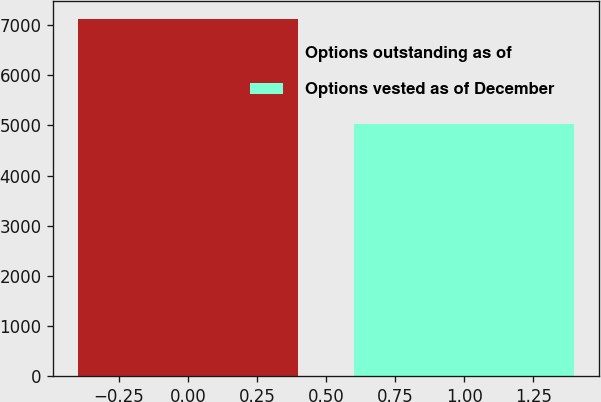Convert chart to OTSL. <chart><loc_0><loc_0><loc_500><loc_500><bar_chart><fcel>Options outstanding as of<fcel>Options vested as of December<nl><fcel>7117<fcel>5036<nl></chart> 